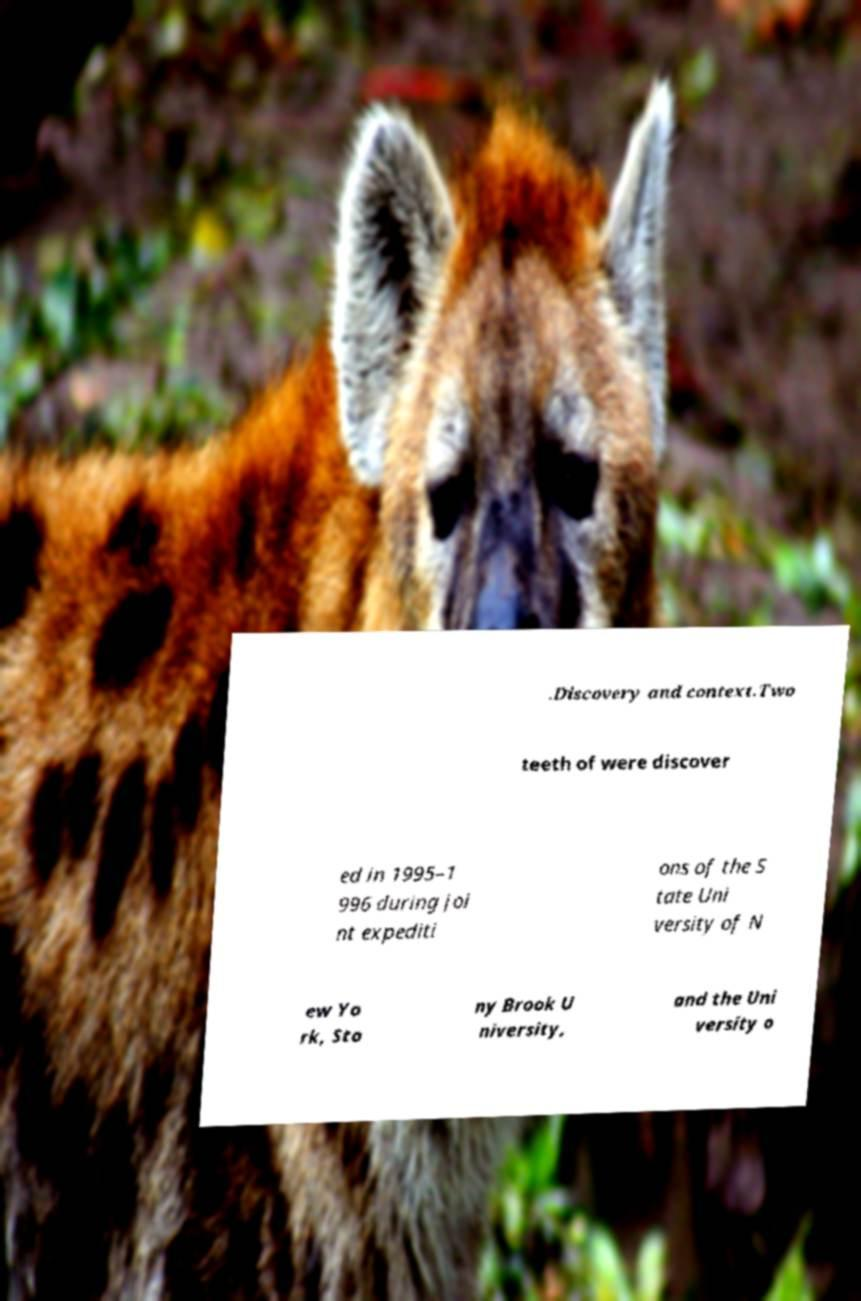Can you accurately transcribe the text from the provided image for me? .Discovery and context.Two teeth of were discover ed in 1995–1 996 during joi nt expediti ons of the S tate Uni versity of N ew Yo rk, Sto ny Brook U niversity, and the Uni versity o 